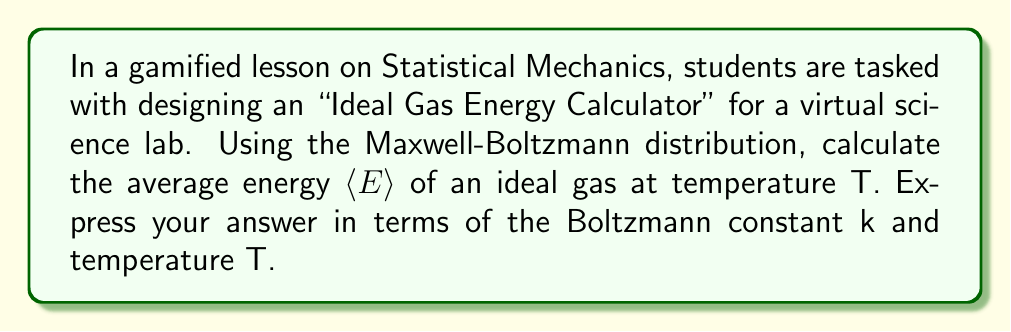What is the answer to this math problem? To solve this problem, we'll follow these steps:

1) The Maxwell-Boltzmann distribution for energy is given by:

   $$f(E) = \frac{2}{\sqrt{\pi}} \frac{E^{1/2}}{(kT)^{3/2}} e^{-E/kT}$$

2) The average energy is calculated using the expectation value:

   $$\langle E \rangle = \int_0^{\infty} E f(E) dE$$

3) Substituting the distribution function:

   $$\langle E \rangle = \int_0^{\infty} E \cdot \frac{2}{\sqrt{\pi}} \frac{E^{1/2}}{(kT)^{3/2}} e^{-E/kT} dE$$

4) Simplifying:

   $$\langle E \rangle = \frac{2}{\sqrt{\pi}(kT)^{3/2}} \int_0^{\infty} E^{3/2} e^{-E/kT} dE$$

5) This integral is a form of the Gamma function. Specifically:

   $$\int_0^{\infty} x^{n-1} e^{-ax} dx = \frac{\Gamma(n)}{a^n}$$

   Here, $n = 5/2$ and $a = 1/kT$

6) Applying this:

   $$\langle E \rangle = \frac{2}{\sqrt{\pi}(kT)^{3/2}} \cdot \frac{\Gamma(5/2)}{(1/kT)^{5/2}}$$

7) Simplify:

   $$\langle E \rangle = \frac{2}{\sqrt{\pi}} \Gamma(5/2) \cdot kT$$

8) We know that $\Gamma(5/2) = \frac{3\sqrt{\pi}}{4}$

9) Substituting and simplifying:

   $$\langle E \rangle = \frac{2}{\sqrt{\pi}} \cdot \frac{3\sqrt{\pi}}{4} \cdot kT = \frac{3}{2}kT$$
Answer: $\langle E \rangle = \frac{3}{2}kT$ 